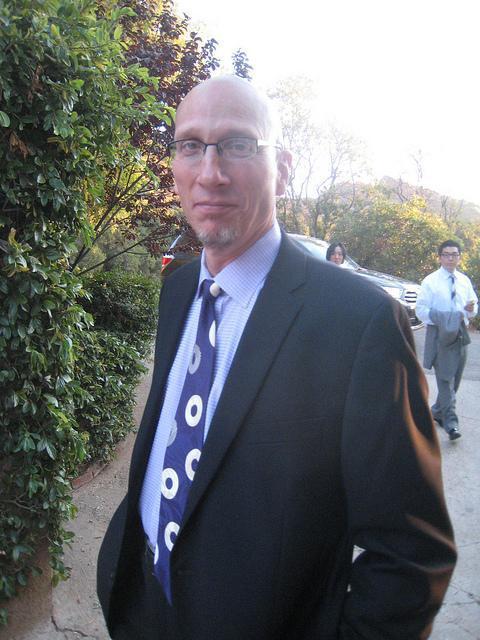How many people are there?
Give a very brief answer. 2. How many beds in this image require a ladder to get into?
Give a very brief answer. 0. 